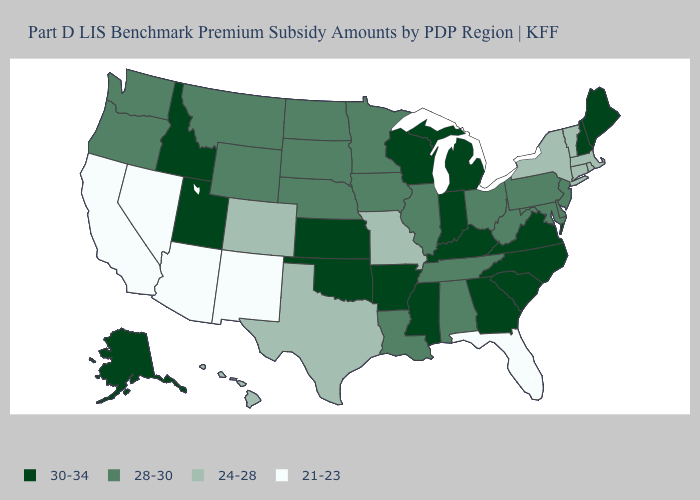Is the legend a continuous bar?
Concise answer only. No. Does Idaho have the highest value in the West?
Write a very short answer. Yes. What is the value of Utah?
Keep it brief. 30-34. What is the lowest value in the MidWest?
Quick response, please. 24-28. What is the value of Wisconsin?
Short answer required. 30-34. Which states have the lowest value in the USA?
Give a very brief answer. Arizona, California, Florida, Nevada, New Mexico. Does Missouri have the lowest value in the MidWest?
Keep it brief. Yes. What is the value of Indiana?
Write a very short answer. 30-34. Among the states that border Texas , does New Mexico have the lowest value?
Write a very short answer. Yes. Does Florida have the lowest value in the South?
Concise answer only. Yes. Name the states that have a value in the range 21-23?
Answer briefly. Arizona, California, Florida, Nevada, New Mexico. Among the states that border New York , does Massachusetts have the lowest value?
Keep it brief. Yes. Name the states that have a value in the range 24-28?
Answer briefly. Colorado, Connecticut, Hawaii, Massachusetts, Missouri, New York, Rhode Island, Texas, Vermont. What is the value of North Dakota?
Answer briefly. 28-30. What is the value of North Carolina?
Be succinct. 30-34. 